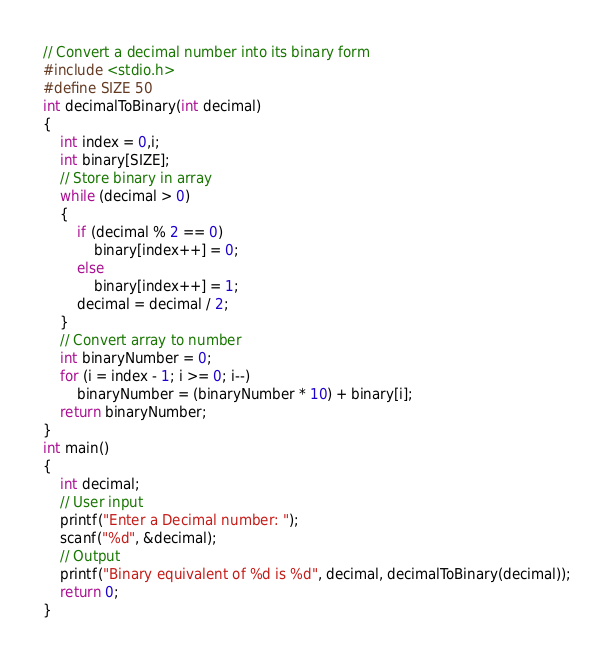Convert code to text. <code><loc_0><loc_0><loc_500><loc_500><_C_>// Convert a decimal number into its binary form
#include <stdio.h>
#define SIZE 50
int decimalToBinary(int decimal)
{
    int index = 0,i;
    int binary[SIZE];
    // Store binary in array
    while (decimal > 0)
    {
        if (decimal % 2 == 0)
            binary[index++] = 0;
        else
            binary[index++] = 1;
        decimal = decimal / 2;
    }
    // Convert array to number
    int binaryNumber = 0;
    for (i = index - 1; i >= 0; i--)
        binaryNumber = (binaryNumber * 10) + binary[i];
    return binaryNumber;
}
int main()
{
    int decimal;
    // User input
    printf("Enter a Decimal number: ");
    scanf("%d", &decimal);
    // Output
    printf("Binary equivalent of %d is %d", decimal, decimalToBinary(decimal));
    return 0;
}
</code> 